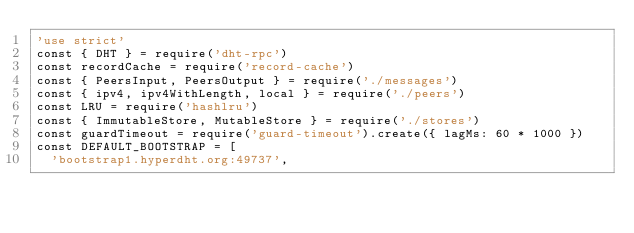<code> <loc_0><loc_0><loc_500><loc_500><_JavaScript_>'use strict'
const { DHT } = require('dht-rpc')
const recordCache = require('record-cache')
const { PeersInput, PeersOutput } = require('./messages')
const { ipv4, ipv4WithLength, local } = require('./peers')
const LRU = require('hashlru')
const { ImmutableStore, MutableStore } = require('./stores')
const guardTimeout = require('guard-timeout').create({ lagMs: 60 * 1000 })
const DEFAULT_BOOTSTRAP = [
  'bootstrap1.hyperdht.org:49737',</code> 